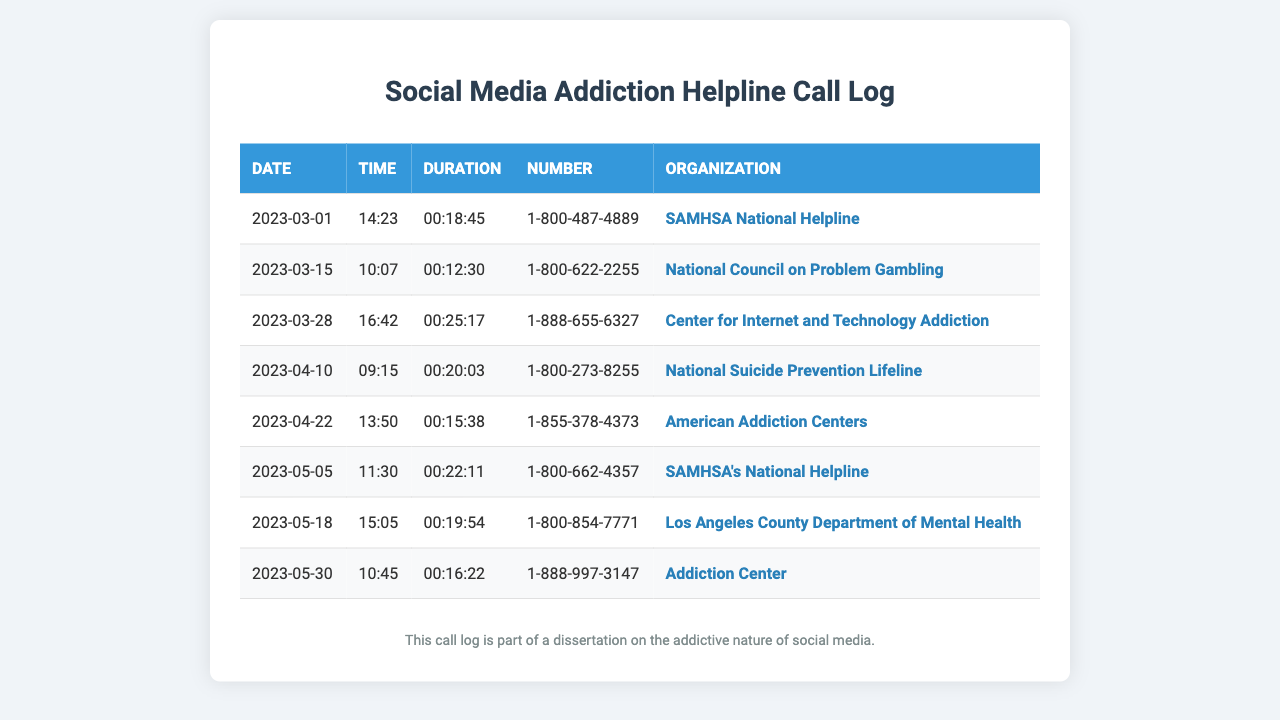What is the first call date? The first call date in the log is the date of the earliest entry listed, which is March 1, 2023.
Answer: March 1, 2023 Who did the longest call go to? The longest call's duration is listed, and corresponds to the entry for the Center for Internet and Technology Addiction, which has the longest recorded duration.
Answer: Center for Internet and Technology Addiction How many calls were made in April? The log lists specific calls by month; there are two calls noted in the log for April.
Answer: 2 What is the duration of the call to the SAMHSA National Helpline on May 5? This information is found in the log for the specific date mentioned; the duration for this call is recorded.
Answer: 00:22:11 What was the time of the call placed on March 15? The time of the call is specified in the entry for that date; referring back to the table shows the correct time.
Answer: 10:07 What organization was contacted on April 22? The document specifies the organization associated with each call; thus, the answer corresponds to the named organization for that date.
Answer: American Addiction Centers How many total calls were made to SAMHSA? The log entries include the organization names, and by counting the entries for SAMHSA, we can find the number.
Answer: 2 